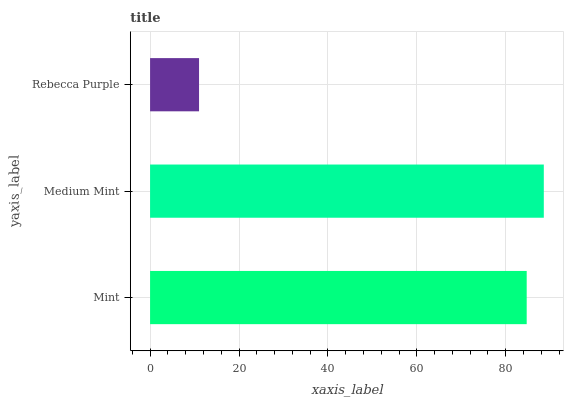Is Rebecca Purple the minimum?
Answer yes or no. Yes. Is Medium Mint the maximum?
Answer yes or no. Yes. Is Medium Mint the minimum?
Answer yes or no. No. Is Rebecca Purple the maximum?
Answer yes or no. No. Is Medium Mint greater than Rebecca Purple?
Answer yes or no. Yes. Is Rebecca Purple less than Medium Mint?
Answer yes or no. Yes. Is Rebecca Purple greater than Medium Mint?
Answer yes or no. No. Is Medium Mint less than Rebecca Purple?
Answer yes or no. No. Is Mint the high median?
Answer yes or no. Yes. Is Mint the low median?
Answer yes or no. Yes. Is Rebecca Purple the high median?
Answer yes or no. No. Is Medium Mint the low median?
Answer yes or no. No. 